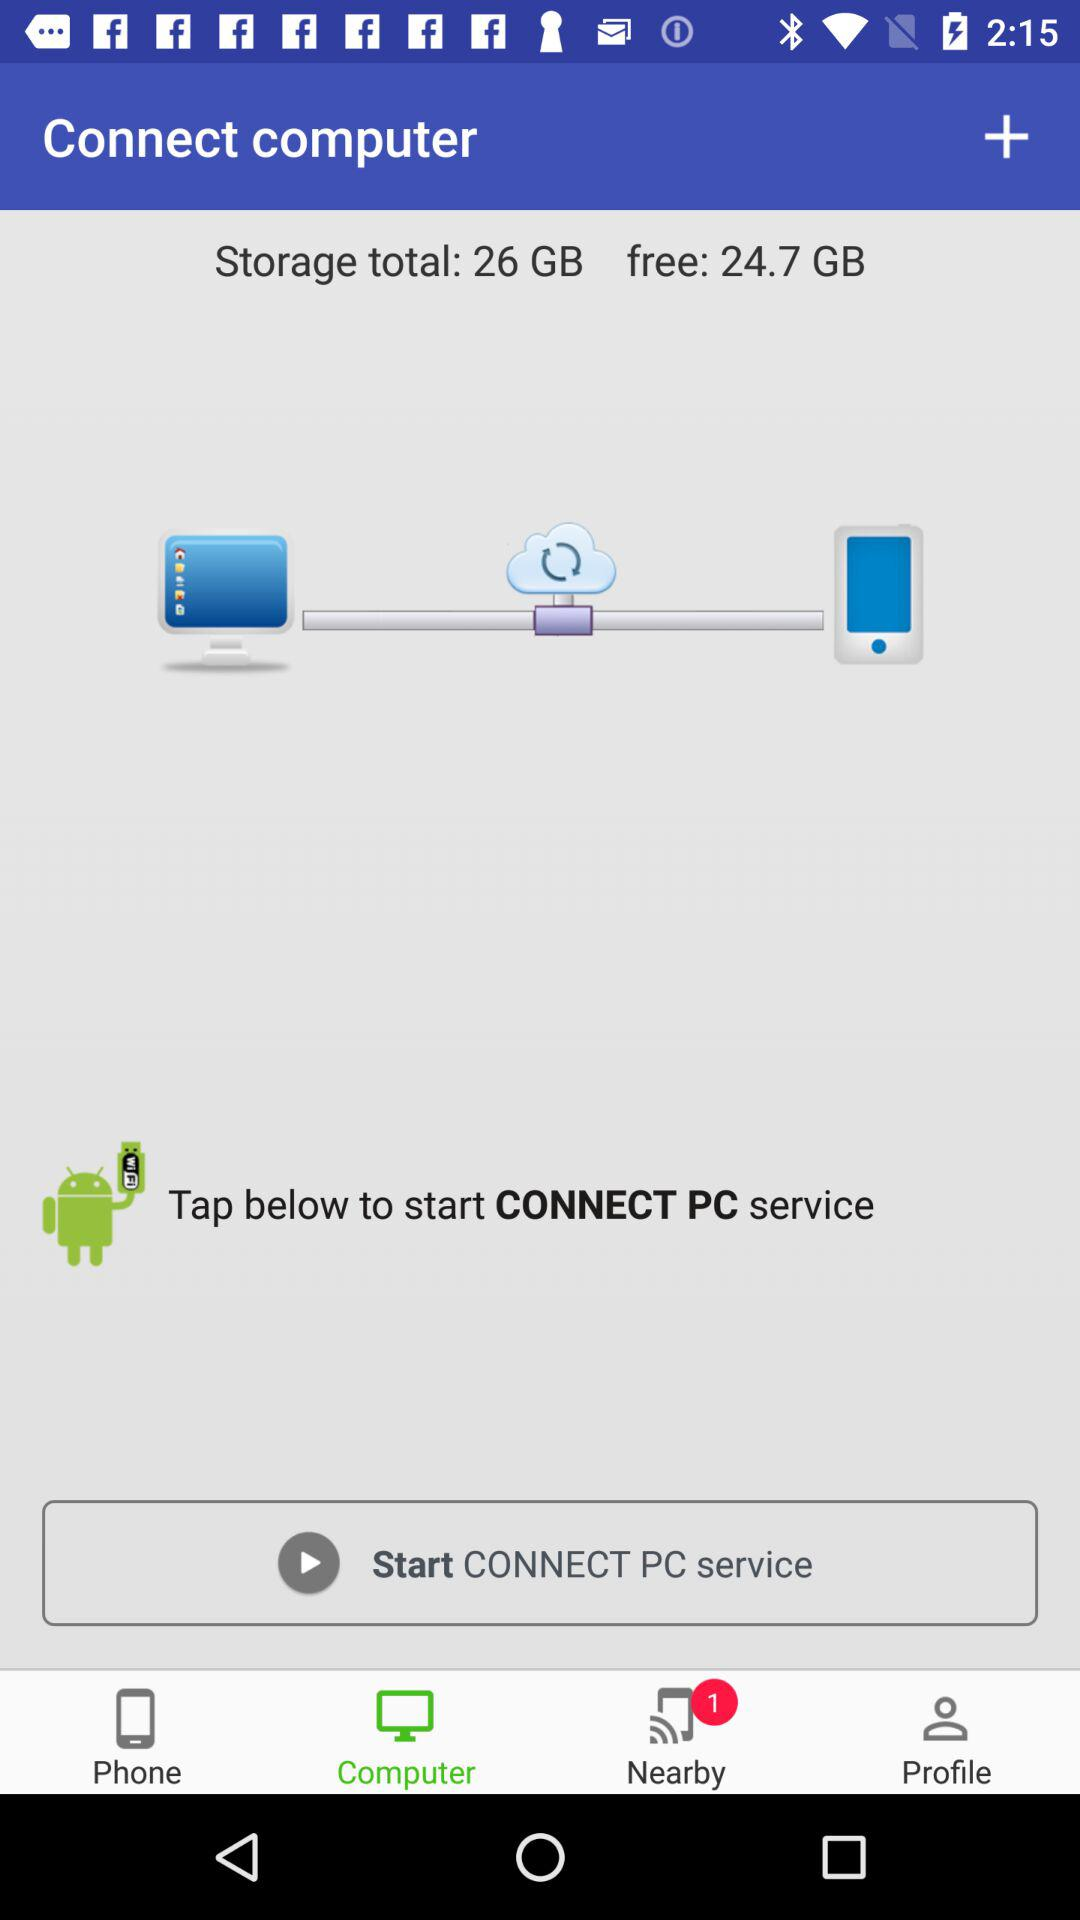What is the amount of free storage available? The amount of free storage available is 24.7 GB. 